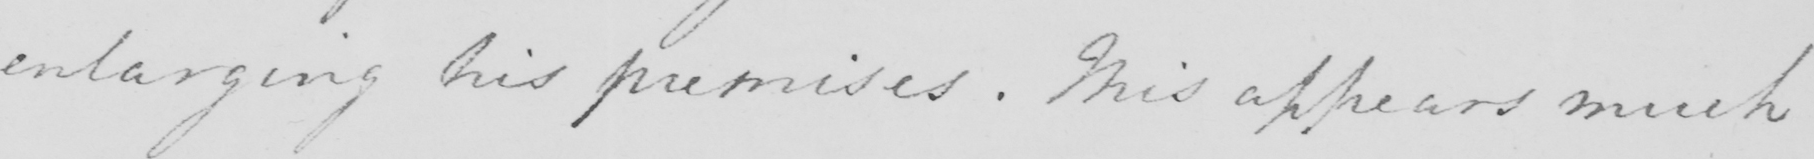What is written in this line of handwriting? enlarging his premises . This appears much 